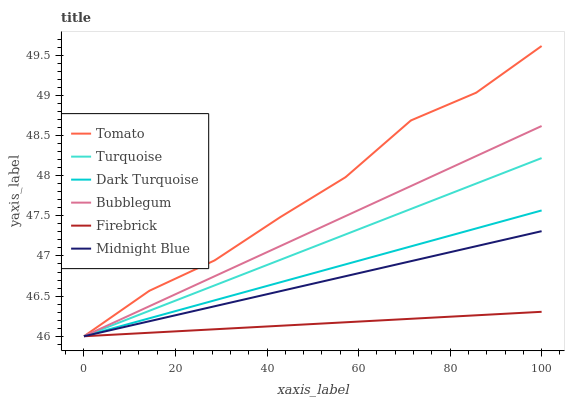Does Firebrick have the minimum area under the curve?
Answer yes or no. Yes. Does Tomato have the maximum area under the curve?
Answer yes or no. Yes. Does Turquoise have the minimum area under the curve?
Answer yes or no. No. Does Turquoise have the maximum area under the curve?
Answer yes or no. No. Is Bubblegum the smoothest?
Answer yes or no. Yes. Is Tomato the roughest?
Answer yes or no. Yes. Is Turquoise the smoothest?
Answer yes or no. No. Is Turquoise the roughest?
Answer yes or no. No. Does Tomato have the highest value?
Answer yes or no. Yes. Does Turquoise have the highest value?
Answer yes or no. No. Does Firebrick intersect Bubblegum?
Answer yes or no. Yes. Is Firebrick less than Bubblegum?
Answer yes or no. No. Is Firebrick greater than Bubblegum?
Answer yes or no. No. 